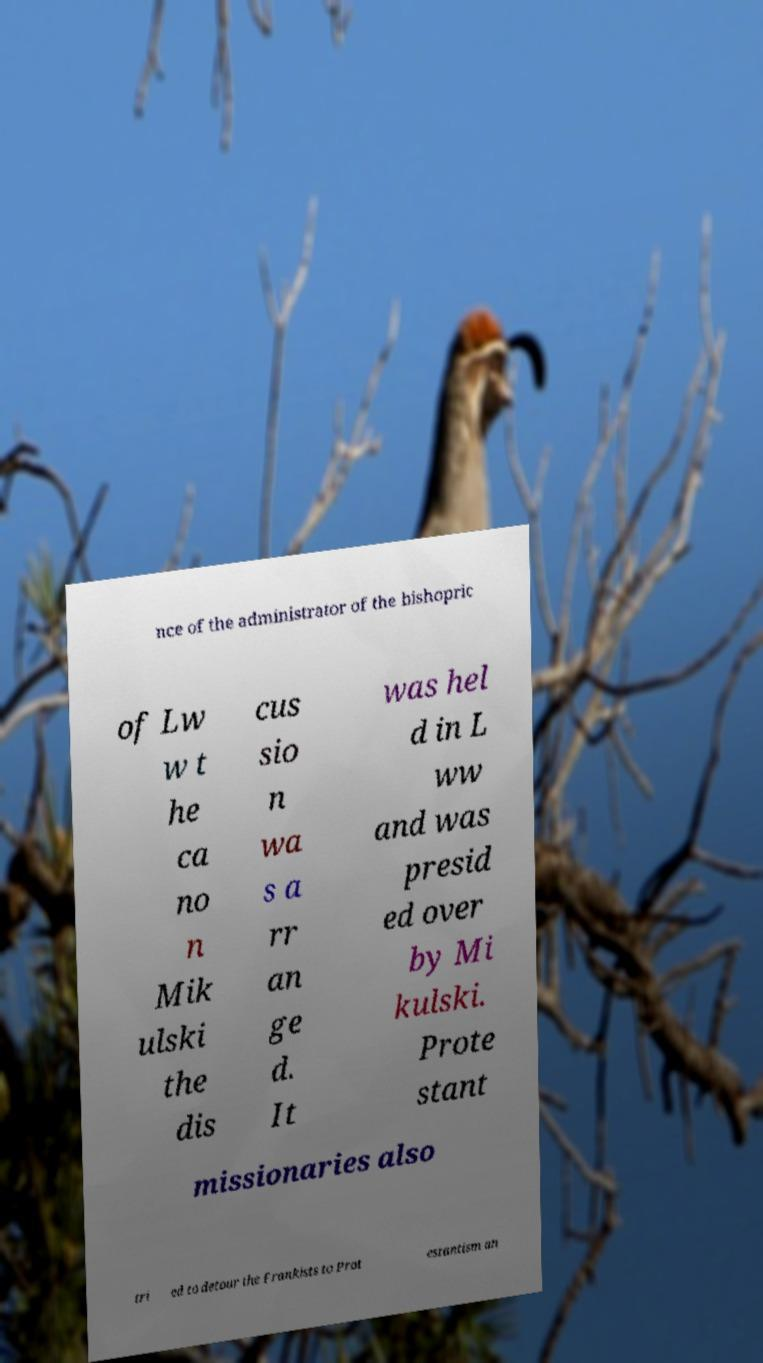Could you extract and type out the text from this image? nce of the administrator of the bishopric of Lw w t he ca no n Mik ulski the dis cus sio n wa s a rr an ge d. It was hel d in L ww and was presid ed over by Mi kulski. Prote stant missionaries also tri ed to detour the Frankists to Prot estantism an 